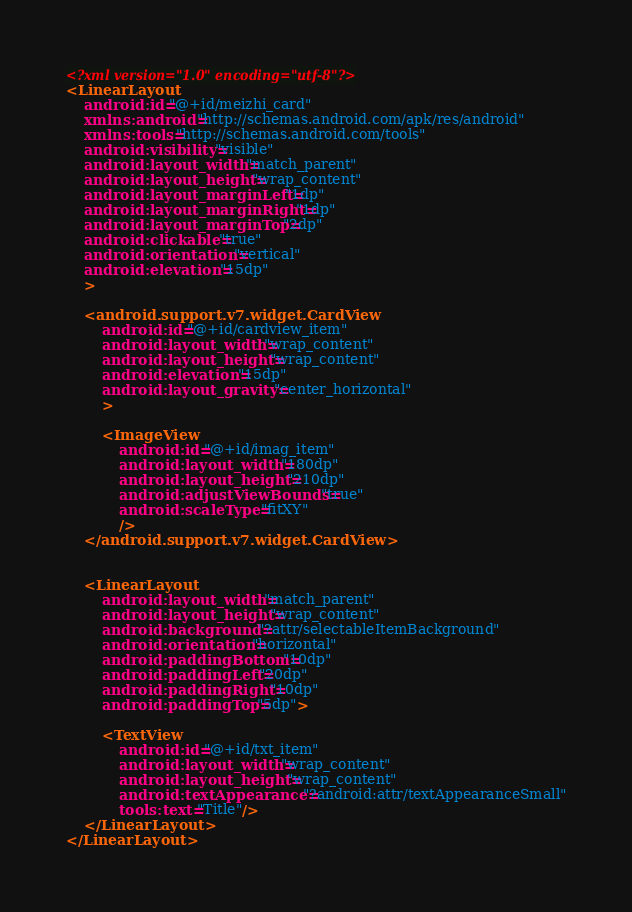Convert code to text. <code><loc_0><loc_0><loc_500><loc_500><_XML_><?xml version="1.0" encoding="utf-8"?>
<LinearLayout
    android:id="@+id/meizhi_card"
    xmlns:android="http://schemas.android.com/apk/res/android"
    xmlns:tools="http://schemas.android.com/tools"
    android:visibility="visible"
    android:layout_width="match_parent"
    android:layout_height="wrap_content"
    android:layout_marginLeft="1dp"
    android:layout_marginRight="1dp"
    android:layout_marginTop="2dp"
    android:clickable="true"
    android:orientation="vertical"
    android:elevation="15dp"
    >

    <android.support.v7.widget.CardView
        android:id="@+id/cardview_item"
        android:layout_width="wrap_content"
        android:layout_height="wrap_content"
        android:elevation="15dp"
        android:layout_gravity="center_horizontal"
        >

        <ImageView
            android:id="@+id/imag_item"
            android:layout_width="180dp"
            android:layout_height="210dp"
            android:adjustViewBounds="true"
            android:scaleType="fitXY"
            />
    </android.support.v7.widget.CardView>


    <LinearLayout
        android:layout_width="match_parent"
        android:layout_height="wrap_content"
        android:background="?attr/selectableItemBackground"
        android:orientation="horizontal"
        android:paddingBottom="10dp"
        android:paddingLeft="20dp"
        android:paddingRight="10dp"
        android:paddingTop="5dp">

        <TextView
            android:id="@+id/txt_item"
            android:layout_width="wrap_content"
            android:layout_height="wrap_content"
            android:textAppearance="?android:attr/textAppearanceSmall"
            tools:text="Title"/>
    </LinearLayout>
</LinearLayout></code> 